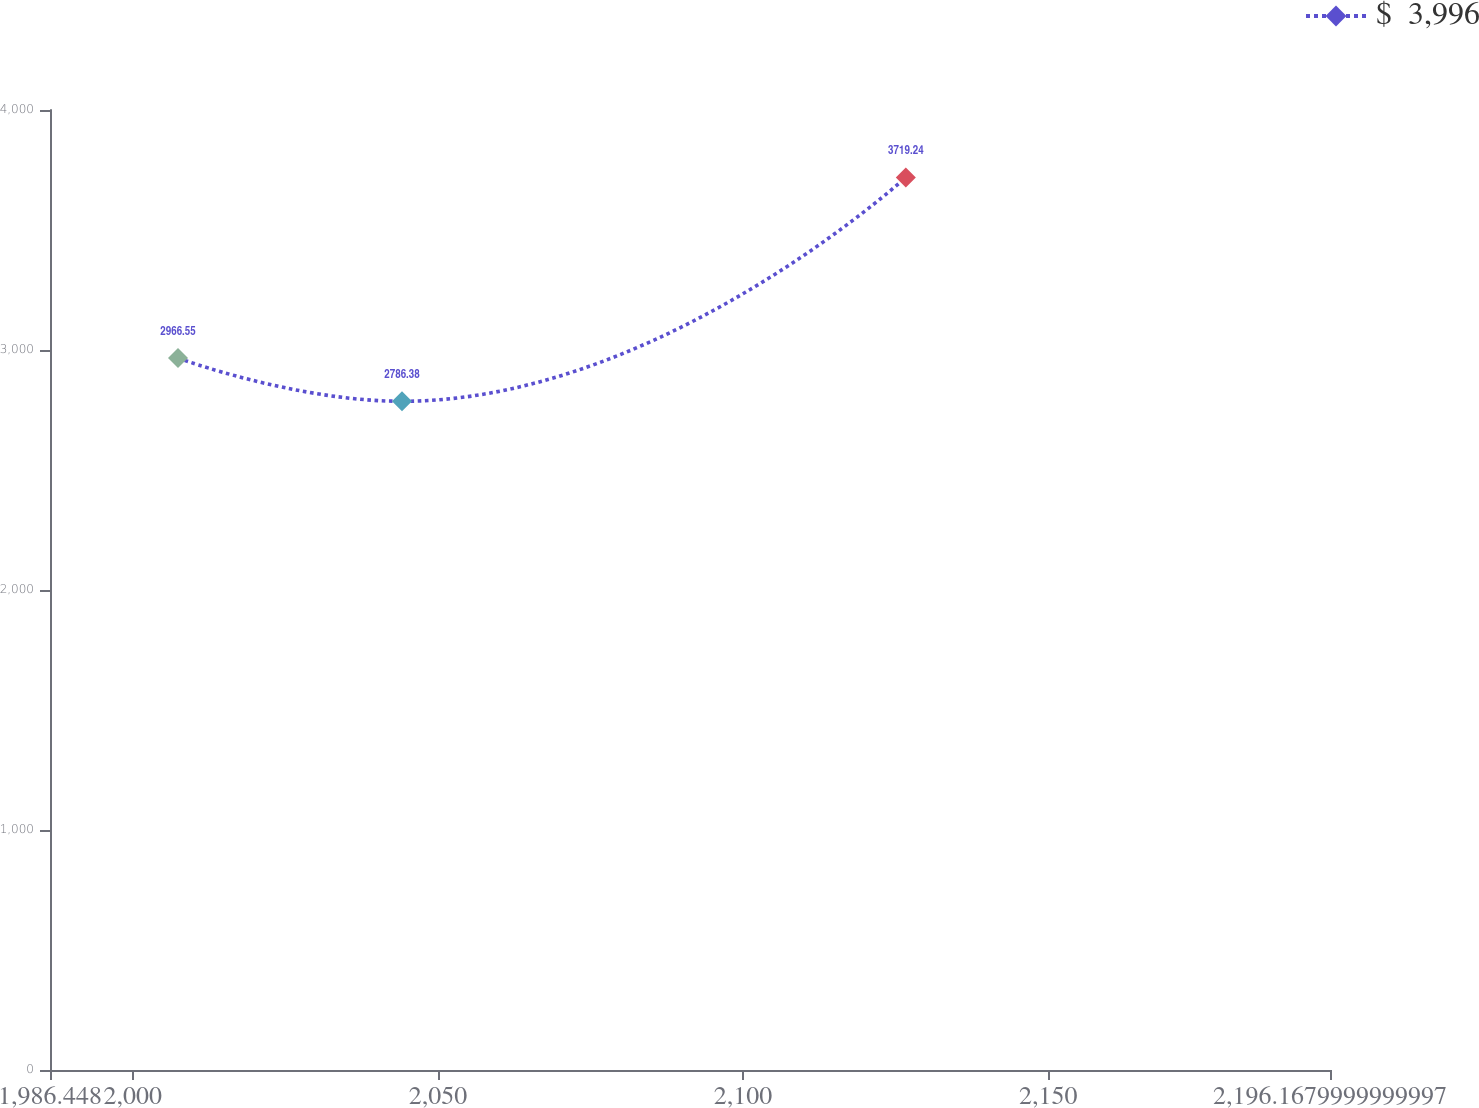Convert chart to OTSL. <chart><loc_0><loc_0><loc_500><loc_500><line_chart><ecel><fcel>$  3,996<nl><fcel>2007.42<fcel>2966.55<nl><fcel>2044.12<fcel>2786.38<nl><fcel>2126.67<fcel>3719.24<nl><fcel>2217.14<fcel>3136<nl></chart> 